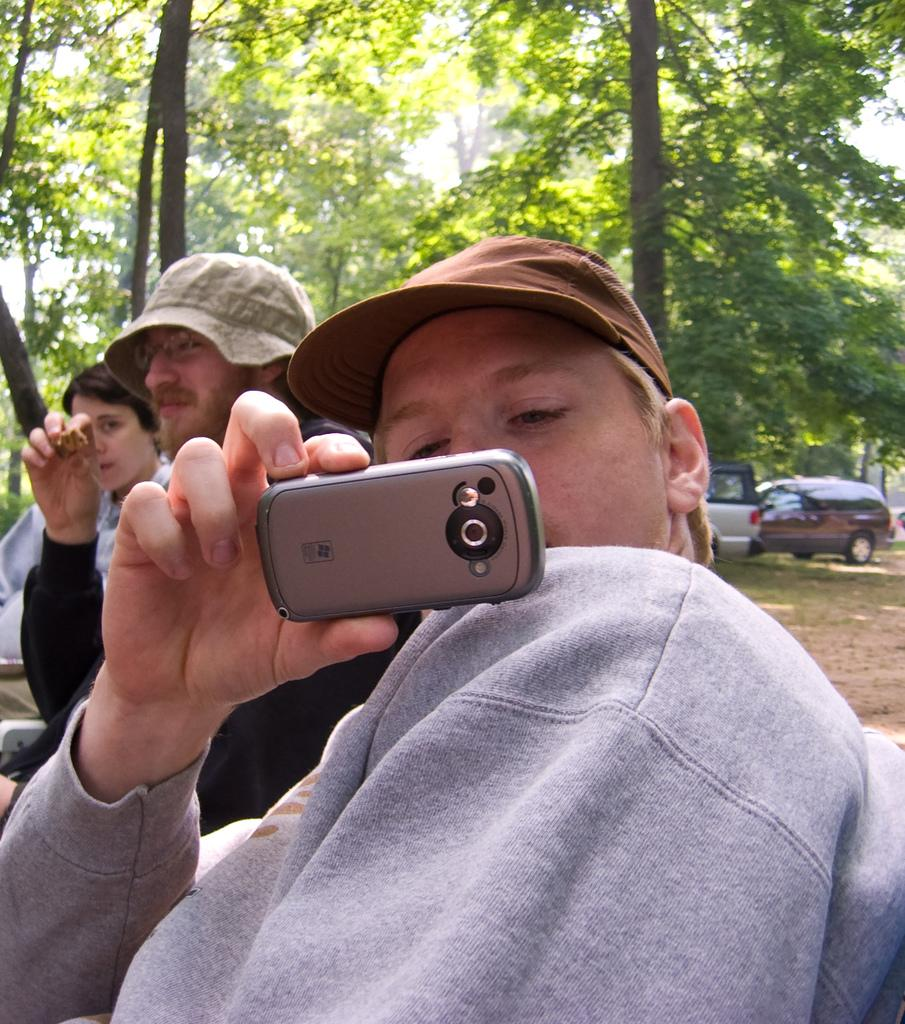How many people are present in the image? There are people in the image, but the exact number is not specified. What is one person doing with their hand in the image? One person is holding a phone in the image. What type of headwear are two people wearing? Two people are wearing caps in the image. What can be seen in the background of the image? There are vehicles and trees in the background of the image. What type of wrench is being used to solve the riddle in the image? There is no wrench or riddle present in the image. What company is sponsoring the event in the image? There is no indication of a company or event in the image. 